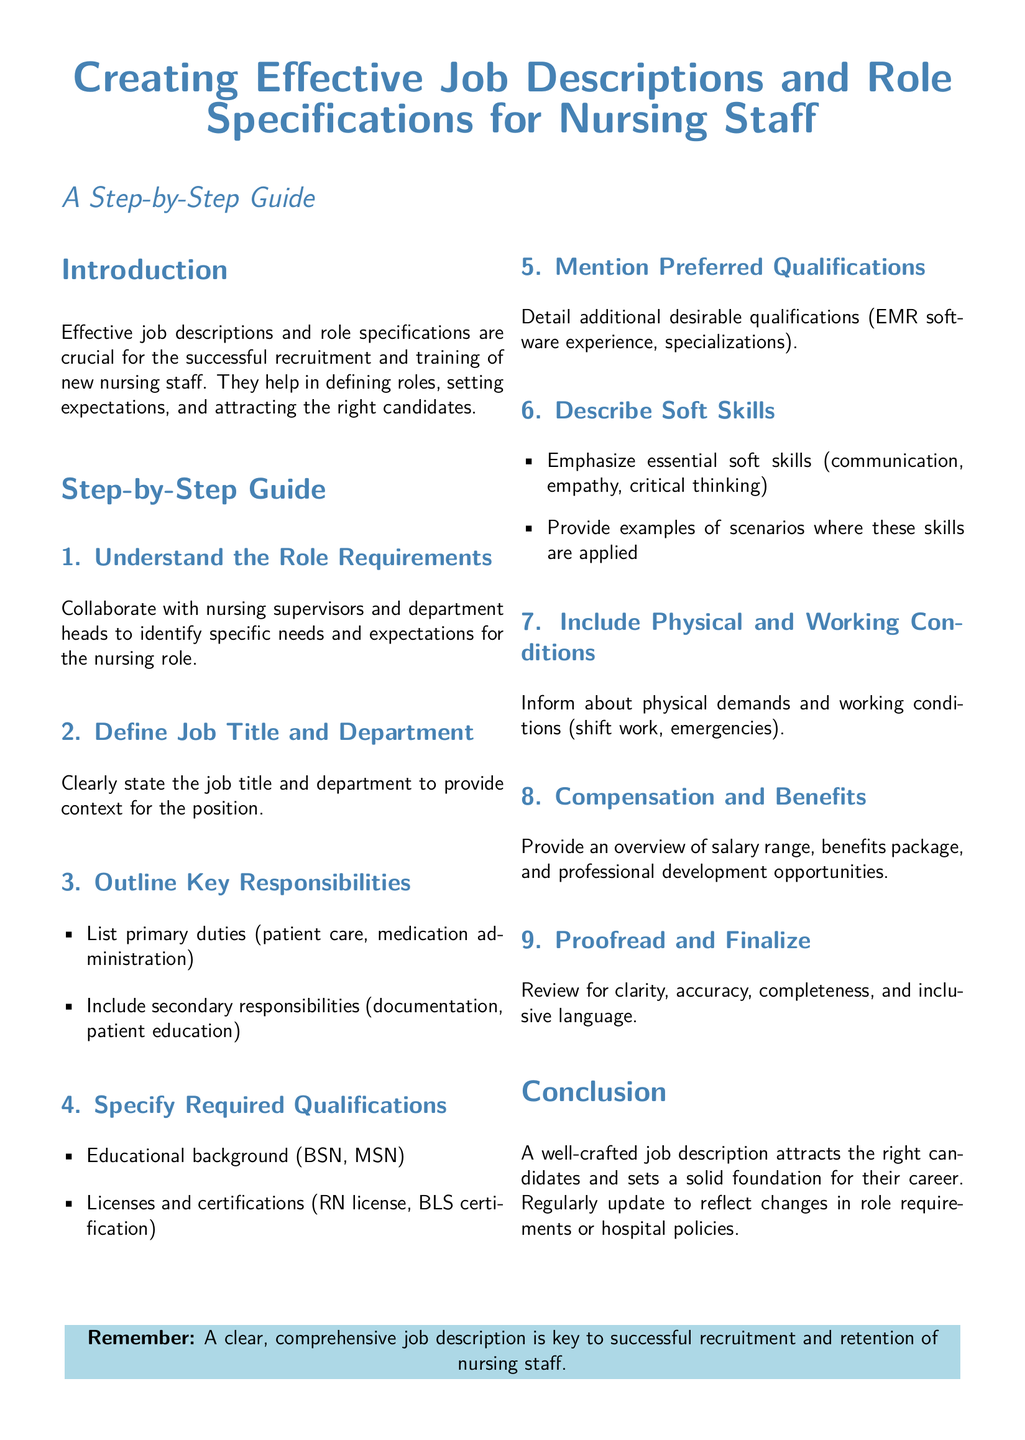What is the focus of the guide? The guide focuses on creating effective job descriptions and role specifications for nursing staff.
Answer: Creating effective job descriptions and role specifications for nursing staff What is the first step in the guide? The first step involves collaborating with nursing supervisors and department heads to identify specific needs and expectations for the nursing role.
Answer: Understand the Role Requirements What should be included in the key responsibilities? The key responsibilities should include primary duties and secondary responsibilities related to the nursing role.
Answer: Primary duties and secondary responsibilities What educational background is specified as required? The required educational background mentioned in the guide is a Bachelor of Science in Nursing (BSN) or Master of Science in Nursing (MSN).
Answer: BSN, MSN What type of skills should be emphasized according to the guide? Essential soft skills that should be emphasized include communication, empathy, and critical thinking.
Answer: Communication, empathy, critical thinking What does the guide recommend proofreading for? The guide recommends proofreading for clarity, accuracy, completeness, and inclusive language.
Answer: Clarity, accuracy, completeness, inclusive language What is the final reminder given in the document? The final reminder emphasizes that a clear, comprehensive job description is key to successful recruitment and retention of nursing staff.
Answer: A clear, comprehensive job description is key to successful recruitment and retention of nursing staff 